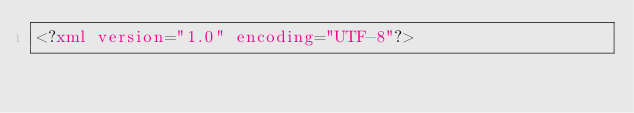Convert code to text. <code><loc_0><loc_0><loc_500><loc_500><_XML_><?xml version="1.0" encoding="UTF-8"?></code> 